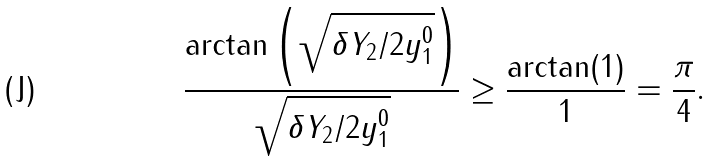Convert formula to latex. <formula><loc_0><loc_0><loc_500><loc_500>\frac { \arctan \left ( \sqrt { \delta Y _ { 2 } / 2 y _ { 1 } ^ { 0 } } \right ) } { \sqrt { { \delta Y _ { 2 } } / { 2 y _ { 1 } ^ { 0 } } } } \geq \frac { \arctan ( 1 ) } { 1 } = \frac { \pi } { 4 } .</formula> 